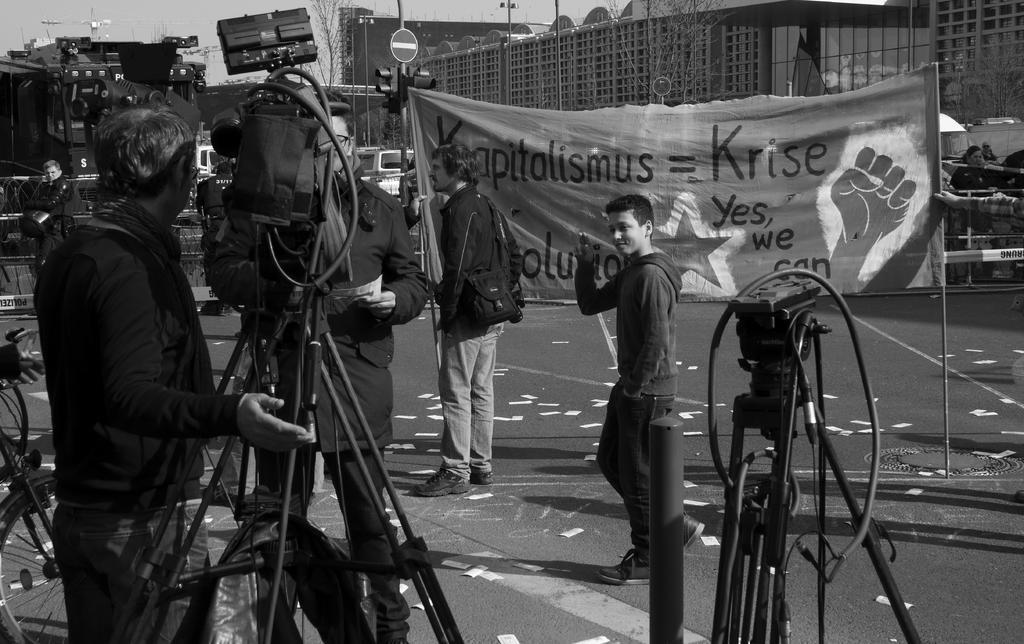Please provide a concise description of this image. In the foreground of this black and white image, there are equipment, tripod stands, bicycle on the left, few people standing and walking on the road, few papers on the road and a banner holding by two people. In the background, there are buildings, sign boards, vehicles, a man walking, poles and the sky. 